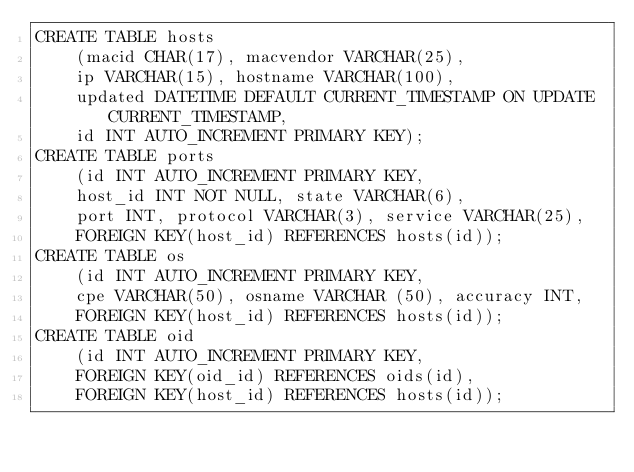Convert code to text. <code><loc_0><loc_0><loc_500><loc_500><_SQL_>CREATE TABLE hosts
	(macid CHAR(17), macvendor VARCHAR(25),
	ip VARCHAR(15), hostname VARCHAR(100),
	updated DATETIME DEFAULT CURRENT_TIMESTAMP ON UPDATE CURRENT_TIMESTAMP, 
	id INT AUTO_INCREMENT PRIMARY KEY);
CREATE TABLE ports
	(id INT AUTO_INCREMENT PRIMARY KEY,
	host_id INT NOT NULL, state VARCHAR(6),
	port INT, protocol VARCHAR(3), service VARCHAR(25),
	FOREIGN KEY(host_id) REFERENCES hosts(id));
CREATE TABLE os
	(id INT AUTO_INCREMENT PRIMARY KEY,
	cpe VARCHAR(50), osname VARCHAR (50), accuracy INT,
	FOREIGN KEY(host_id) REFERENCES hosts(id));
CREATE TABLE oid
    (id INT AUTO_INCREMENT PRIMARY KEY,
    FOREIGN KEY(oid_id) REFERENCES oids(id),
    FOREIGN KEY(host_id) REFERENCES hosts(id));</code> 